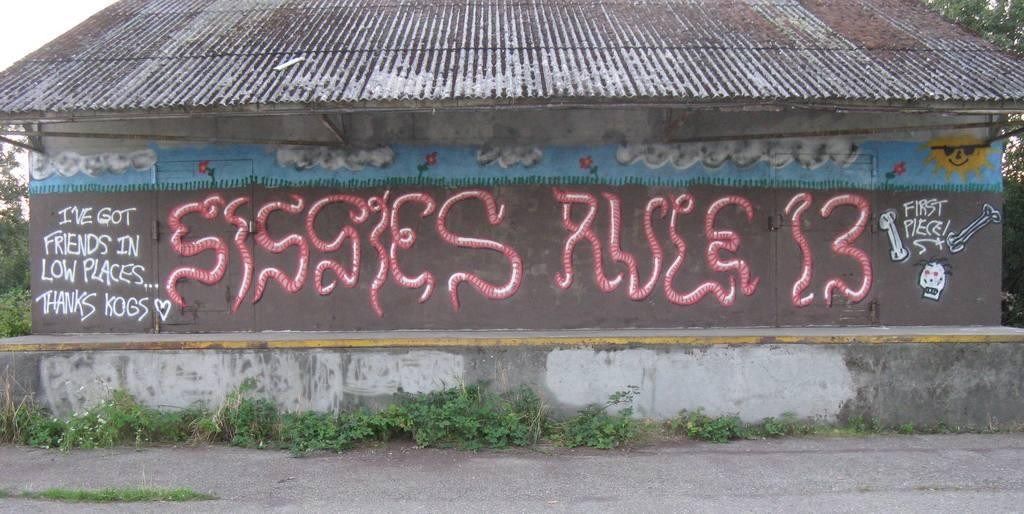What is the main subject in the center of the image? There is a house in the center of the image. What can be seen on the walls of the house? There is a painting on the walls of the house. What is located at the bottom of the image? There is a road at the bottom of the image. What type of vegetation is visible in the image? There are plants visible in the image. What type of office can be seen in the image? There is no office present in the image; it features a house with a painting on the walls, a road at the bottom, and plants visible. How much salt is sprinkled on the plants in the image? There is no salt visible in the image; it only shows plants as part of the setting. 